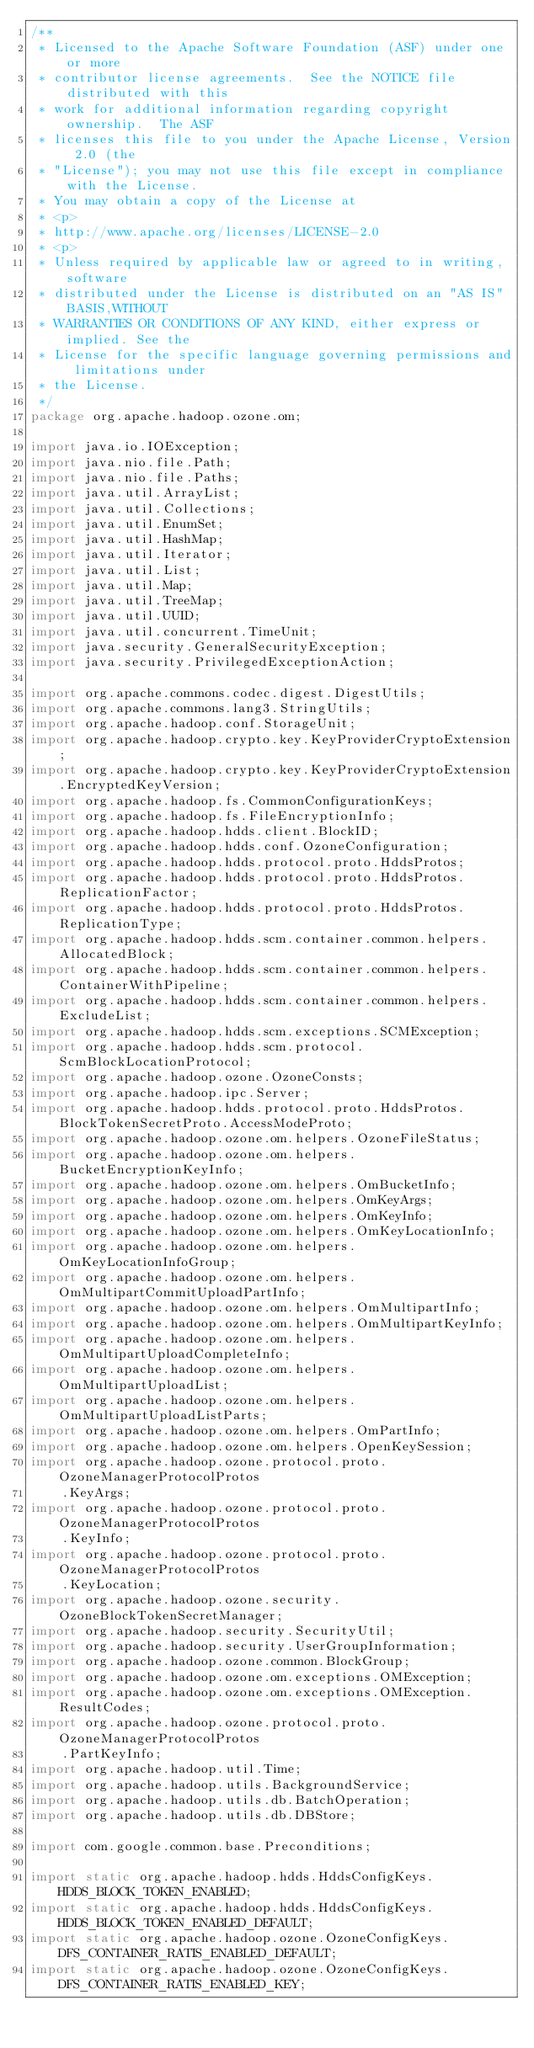<code> <loc_0><loc_0><loc_500><loc_500><_Java_>/**
 * Licensed to the Apache Software Foundation (ASF) under one or more
 * contributor license agreements.  See the NOTICE file distributed with this
 * work for additional information regarding copyright ownership.  The ASF
 * licenses this file to you under the Apache License, Version 2.0 (the
 * "License"); you may not use this file except in compliance with the License.
 * You may obtain a copy of the License at
 * <p>
 * http://www.apache.org/licenses/LICENSE-2.0
 * <p>
 * Unless required by applicable law or agreed to in writing, software
 * distributed under the License is distributed on an "AS IS" BASIS,WITHOUT
 * WARRANTIES OR CONDITIONS OF ANY KIND, either express or implied. See the
 * License for the specific language governing permissions and limitations under
 * the License.
 */
package org.apache.hadoop.ozone.om;

import java.io.IOException;
import java.nio.file.Path;
import java.nio.file.Paths;
import java.util.ArrayList;
import java.util.Collections;
import java.util.EnumSet;
import java.util.HashMap;
import java.util.Iterator;
import java.util.List;
import java.util.Map;
import java.util.TreeMap;
import java.util.UUID;
import java.util.concurrent.TimeUnit;
import java.security.GeneralSecurityException;
import java.security.PrivilegedExceptionAction;

import org.apache.commons.codec.digest.DigestUtils;
import org.apache.commons.lang3.StringUtils;
import org.apache.hadoop.conf.StorageUnit;
import org.apache.hadoop.crypto.key.KeyProviderCryptoExtension;
import org.apache.hadoop.crypto.key.KeyProviderCryptoExtension.EncryptedKeyVersion;
import org.apache.hadoop.fs.CommonConfigurationKeys;
import org.apache.hadoop.fs.FileEncryptionInfo;
import org.apache.hadoop.hdds.client.BlockID;
import org.apache.hadoop.hdds.conf.OzoneConfiguration;
import org.apache.hadoop.hdds.protocol.proto.HddsProtos;
import org.apache.hadoop.hdds.protocol.proto.HddsProtos.ReplicationFactor;
import org.apache.hadoop.hdds.protocol.proto.HddsProtos.ReplicationType;
import org.apache.hadoop.hdds.scm.container.common.helpers.AllocatedBlock;
import org.apache.hadoop.hdds.scm.container.common.helpers.ContainerWithPipeline;
import org.apache.hadoop.hdds.scm.container.common.helpers.ExcludeList;
import org.apache.hadoop.hdds.scm.exceptions.SCMException;
import org.apache.hadoop.hdds.scm.protocol.ScmBlockLocationProtocol;
import org.apache.hadoop.ozone.OzoneConsts;
import org.apache.hadoop.ipc.Server;
import org.apache.hadoop.hdds.protocol.proto.HddsProtos.BlockTokenSecretProto.AccessModeProto;
import org.apache.hadoop.ozone.om.helpers.OzoneFileStatus;
import org.apache.hadoop.ozone.om.helpers.BucketEncryptionKeyInfo;
import org.apache.hadoop.ozone.om.helpers.OmBucketInfo;
import org.apache.hadoop.ozone.om.helpers.OmKeyArgs;
import org.apache.hadoop.ozone.om.helpers.OmKeyInfo;
import org.apache.hadoop.ozone.om.helpers.OmKeyLocationInfo;
import org.apache.hadoop.ozone.om.helpers.OmKeyLocationInfoGroup;
import org.apache.hadoop.ozone.om.helpers.OmMultipartCommitUploadPartInfo;
import org.apache.hadoop.ozone.om.helpers.OmMultipartInfo;
import org.apache.hadoop.ozone.om.helpers.OmMultipartKeyInfo;
import org.apache.hadoop.ozone.om.helpers.OmMultipartUploadCompleteInfo;
import org.apache.hadoop.ozone.om.helpers.OmMultipartUploadList;
import org.apache.hadoop.ozone.om.helpers.OmMultipartUploadListParts;
import org.apache.hadoop.ozone.om.helpers.OmPartInfo;
import org.apache.hadoop.ozone.om.helpers.OpenKeySession;
import org.apache.hadoop.ozone.protocol.proto.OzoneManagerProtocolProtos
    .KeyArgs;
import org.apache.hadoop.ozone.protocol.proto.OzoneManagerProtocolProtos
    .KeyInfo;
import org.apache.hadoop.ozone.protocol.proto.OzoneManagerProtocolProtos
    .KeyLocation;
import org.apache.hadoop.ozone.security.OzoneBlockTokenSecretManager;
import org.apache.hadoop.security.SecurityUtil;
import org.apache.hadoop.security.UserGroupInformation;
import org.apache.hadoop.ozone.common.BlockGroup;
import org.apache.hadoop.ozone.om.exceptions.OMException;
import org.apache.hadoop.ozone.om.exceptions.OMException.ResultCodes;
import org.apache.hadoop.ozone.protocol.proto.OzoneManagerProtocolProtos
    .PartKeyInfo;
import org.apache.hadoop.util.Time;
import org.apache.hadoop.utils.BackgroundService;
import org.apache.hadoop.utils.db.BatchOperation;
import org.apache.hadoop.utils.db.DBStore;

import com.google.common.base.Preconditions;

import static org.apache.hadoop.hdds.HddsConfigKeys.HDDS_BLOCK_TOKEN_ENABLED;
import static org.apache.hadoop.hdds.HddsConfigKeys.HDDS_BLOCK_TOKEN_ENABLED_DEFAULT;
import static org.apache.hadoop.ozone.OzoneConfigKeys.DFS_CONTAINER_RATIS_ENABLED_DEFAULT;
import static org.apache.hadoop.ozone.OzoneConfigKeys.DFS_CONTAINER_RATIS_ENABLED_KEY;</code> 